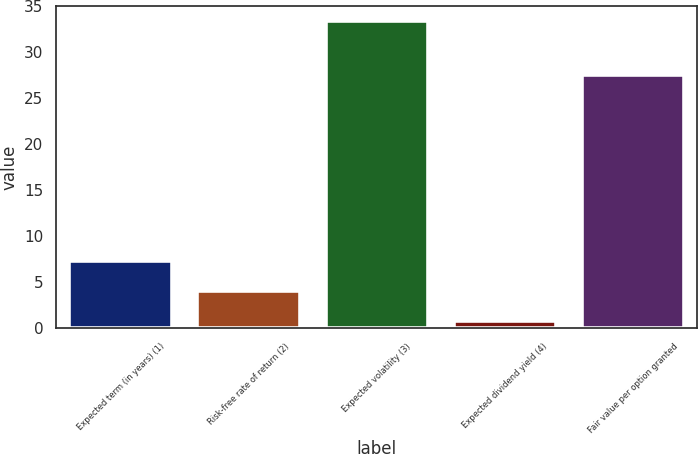Convert chart to OTSL. <chart><loc_0><loc_0><loc_500><loc_500><bar_chart><fcel>Expected term (in years) (1)<fcel>Risk-free rate of return (2)<fcel>Expected volatility (3)<fcel>Expected dividend yield (4)<fcel>Fair value per option granted<nl><fcel>7.32<fcel>4.06<fcel>33.4<fcel>0.8<fcel>27.5<nl></chart> 